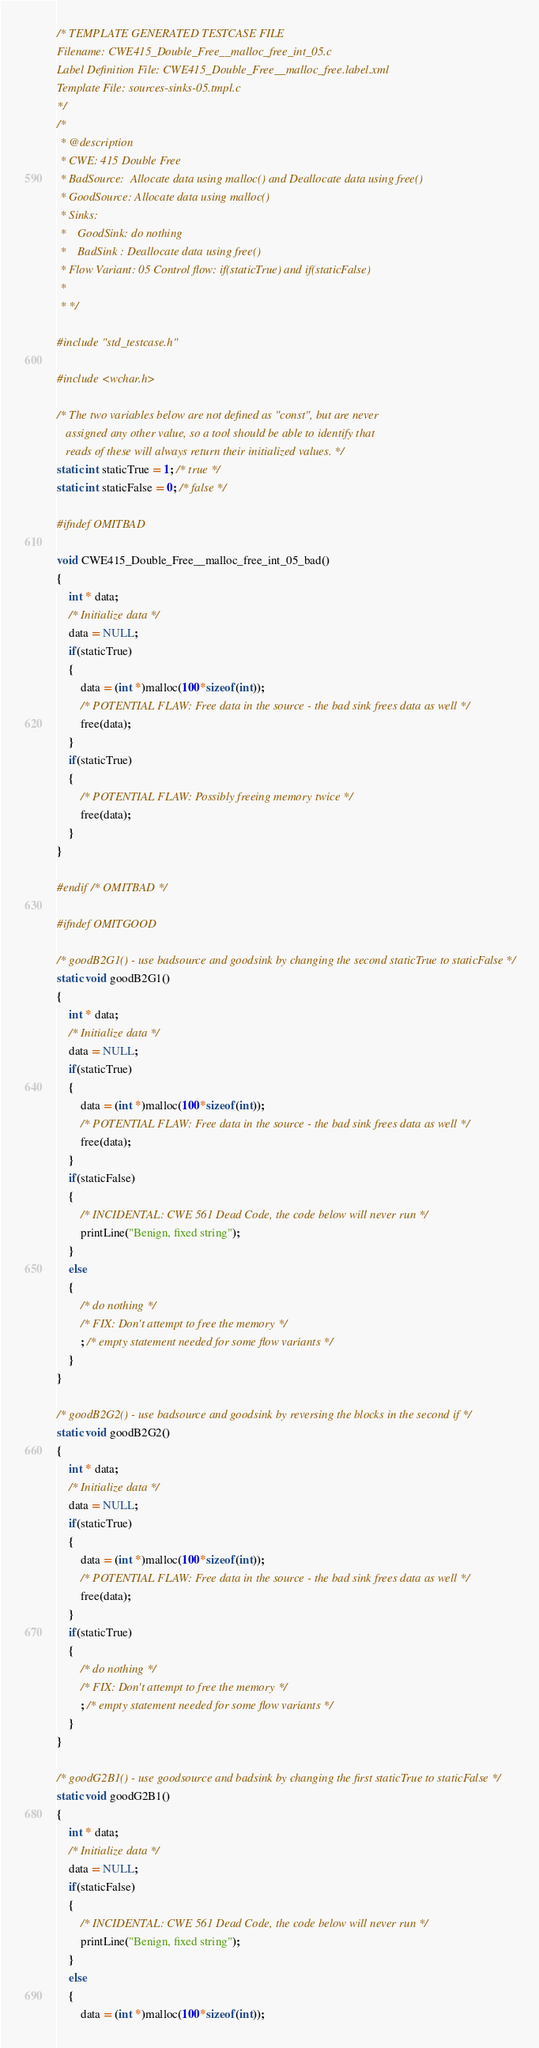<code> <loc_0><loc_0><loc_500><loc_500><_C_>/* TEMPLATE GENERATED TESTCASE FILE
Filename: CWE415_Double_Free__malloc_free_int_05.c
Label Definition File: CWE415_Double_Free__malloc_free.label.xml
Template File: sources-sinks-05.tmpl.c
*/
/*
 * @description
 * CWE: 415 Double Free
 * BadSource:  Allocate data using malloc() and Deallocate data using free()
 * GoodSource: Allocate data using malloc()
 * Sinks:
 *    GoodSink: do nothing
 *    BadSink : Deallocate data using free()
 * Flow Variant: 05 Control flow: if(staticTrue) and if(staticFalse)
 *
 * */

#include "std_testcase.h"

#include <wchar.h>

/* The two variables below are not defined as "const", but are never
   assigned any other value, so a tool should be able to identify that
   reads of these will always return their initialized values. */
static int staticTrue = 1; /* true */
static int staticFalse = 0; /* false */

#ifndef OMITBAD

void CWE415_Double_Free__malloc_free_int_05_bad()
{
    int * data;
    /* Initialize data */
    data = NULL;
    if(staticTrue)
    {
        data = (int *)malloc(100*sizeof(int));
        /* POTENTIAL FLAW: Free data in the source - the bad sink frees data as well */
        free(data);
    }
    if(staticTrue)
    {
        /* POTENTIAL FLAW: Possibly freeing memory twice */
        free(data);
    }
}

#endif /* OMITBAD */

#ifndef OMITGOOD

/* goodB2G1() - use badsource and goodsink by changing the second staticTrue to staticFalse */
static void goodB2G1()
{
    int * data;
    /* Initialize data */
    data = NULL;
    if(staticTrue)
    {
        data = (int *)malloc(100*sizeof(int));
        /* POTENTIAL FLAW: Free data in the source - the bad sink frees data as well */
        free(data);
    }
    if(staticFalse)
    {
        /* INCIDENTAL: CWE 561 Dead Code, the code below will never run */
        printLine("Benign, fixed string");
    }
    else
    {
        /* do nothing */
        /* FIX: Don't attempt to free the memory */
        ; /* empty statement needed for some flow variants */
    }
}

/* goodB2G2() - use badsource and goodsink by reversing the blocks in the second if */
static void goodB2G2()
{
    int * data;
    /* Initialize data */
    data = NULL;
    if(staticTrue)
    {
        data = (int *)malloc(100*sizeof(int));
        /* POTENTIAL FLAW: Free data in the source - the bad sink frees data as well */
        free(data);
    }
    if(staticTrue)
    {
        /* do nothing */
        /* FIX: Don't attempt to free the memory */
        ; /* empty statement needed for some flow variants */
    }
}

/* goodG2B1() - use goodsource and badsink by changing the first staticTrue to staticFalse */
static void goodG2B1()
{
    int * data;
    /* Initialize data */
    data = NULL;
    if(staticFalse)
    {
        /* INCIDENTAL: CWE 561 Dead Code, the code below will never run */
        printLine("Benign, fixed string");
    }
    else
    {
        data = (int *)malloc(100*sizeof(int));</code> 